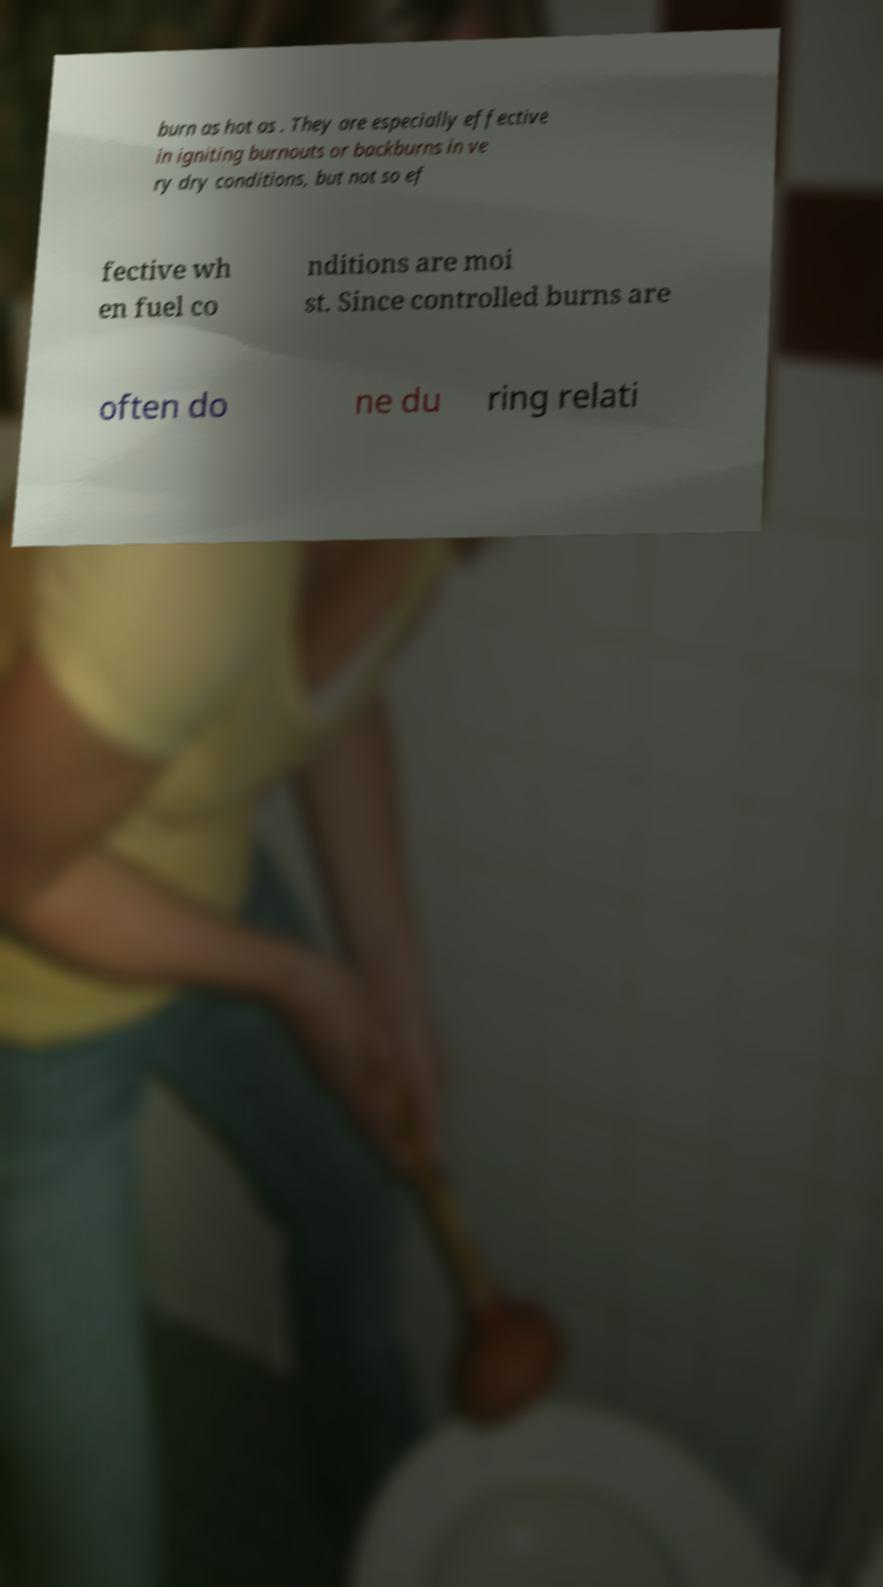Please identify and transcribe the text found in this image. burn as hot as . They are especially effective in igniting burnouts or backburns in ve ry dry conditions, but not so ef fective wh en fuel co nditions are moi st. Since controlled burns are often do ne du ring relati 